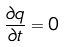Convert formula to latex. <formula><loc_0><loc_0><loc_500><loc_500>\frac { \partial q } { \partial t } = 0</formula> 